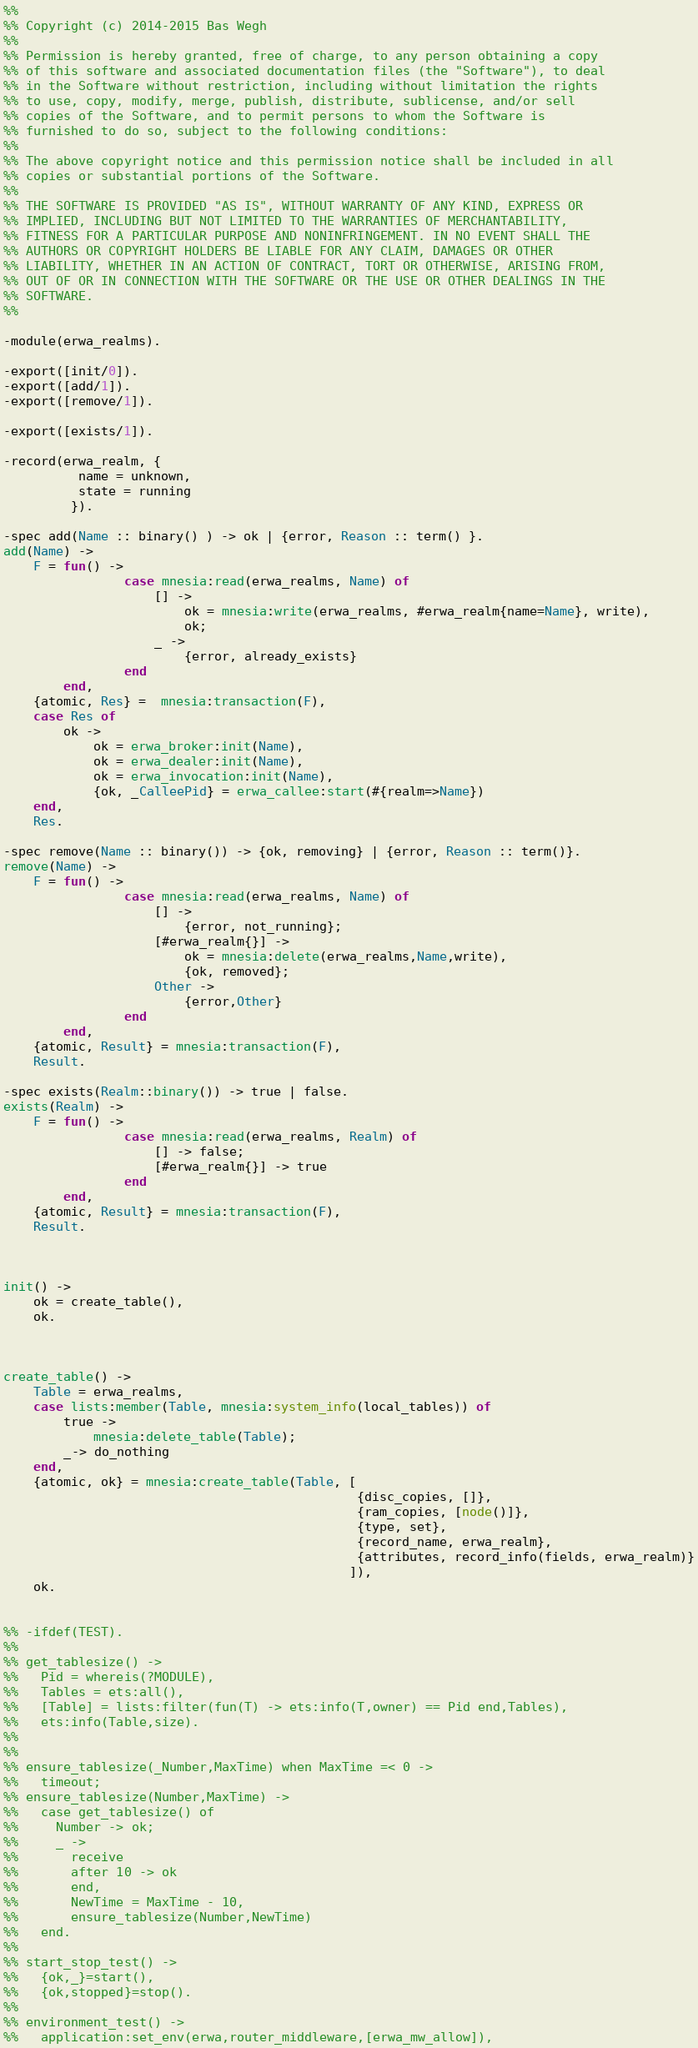<code> <loc_0><loc_0><loc_500><loc_500><_Erlang_>%%
%% Copyright (c) 2014-2015 Bas Wegh
%%
%% Permission is hereby granted, free of charge, to any person obtaining a copy
%% of this software and associated documentation files (the "Software"), to deal
%% in the Software without restriction, including without limitation the rights
%% to use, copy, modify, merge, publish, distribute, sublicense, and/or sell
%% copies of the Software, and to permit persons to whom the Software is
%% furnished to do so, subject to the following conditions:
%%
%% The above copyright notice and this permission notice shall be included in all
%% copies or substantial portions of the Software.
%%
%% THE SOFTWARE IS PROVIDED "AS IS", WITHOUT WARRANTY OF ANY KIND, EXPRESS OR
%% IMPLIED, INCLUDING BUT NOT LIMITED TO THE WARRANTIES OF MERCHANTABILITY,
%% FITNESS FOR A PARTICULAR PURPOSE AND NONINFRINGEMENT. IN NO EVENT SHALL THE
%% AUTHORS OR COPYRIGHT HOLDERS BE LIABLE FOR ANY CLAIM, DAMAGES OR OTHER
%% LIABILITY, WHETHER IN AN ACTION OF CONTRACT, TORT OR OTHERWISE, ARISING FROM,
%% OUT OF OR IN CONNECTION WITH THE SOFTWARE OR THE USE OR OTHER DEALINGS IN THE
%% SOFTWARE.
%%

-module(erwa_realms).

-export([init/0]).
-export([add/1]).
-export([remove/1]).

-export([exists/1]).

-record(erwa_realm, {
          name = unknown,
          state = running
         }).

-spec add(Name :: binary() ) -> ok | {error, Reason :: term() }.
add(Name) ->
    F = fun() -> 
                case mnesia:read(erwa_realms, Name) of 
                    [] ->
                        ok = mnesia:write(erwa_realms, #erwa_realm{name=Name}, write),
                        ok;
                    _ -> 
                        {error, already_exists}
                end 
        end,
    {atomic, Res} =  mnesia:transaction(F),
    case Res of
        ok ->
            ok = erwa_broker:init(Name),
            ok = erwa_dealer:init(Name),
            ok = erwa_invocation:init(Name),
            {ok, _CalleePid} = erwa_callee:start(#{realm=>Name})
    end,
    Res.

-spec remove(Name :: binary()) -> {ok, removing} | {error, Reason :: term()}.
remove(Name) ->
    F = fun() ->
                case mnesia:read(erwa_realms, Name) of
                    [] ->
                        {error, not_running};
                    [#erwa_realm{}] ->
                        ok = mnesia:delete(erwa_realms,Name,write),
                        {ok, removed};
                    Other ->
                        {error,Other}
                end 
        end,
    {atomic, Result} = mnesia:transaction(F),
    Result.

-spec exists(Realm::binary()) -> true | false.
exists(Realm) ->
    F = fun() ->
                case mnesia:read(erwa_realms, Realm) of 
                    [] -> false;
                    [#erwa_realm{}] -> true 
                end 
        end,
    {atomic, Result} = mnesia:transaction(F),
    Result.



init() ->
    ok = create_table(),
    ok.



create_table() ->
    Table = erwa_realms,
	case lists:member(Table, mnesia:system_info(local_tables)) of
		true ->
			mnesia:delete_table(Table);
		_-> do_nothing
	end,
	{atomic, ok} = mnesia:create_table(Table, [
                                               {disc_copies, []},
                                               {ram_copies, [node()]}, 
                                               {type, set},
                                               {record_name, erwa_realm},
                                               {attributes, record_info(fields, erwa_realm)}
                                              ]),
	ok.


%% -ifdef(TEST).
%%
%% get_tablesize() ->
%%   Pid = whereis(?MODULE),
%%   Tables = ets:all(),
%%   [Table] = lists:filter(fun(T) -> ets:info(T,owner) == Pid end,Tables),
%%   ets:info(Table,size).
%%
%%
%% ensure_tablesize(_Number,MaxTime) when MaxTime =< 0 ->
%%   timeout;
%% ensure_tablesize(Number,MaxTime) ->
%%   case get_tablesize() of
%%     Number -> ok;
%%     _ ->
%%       receive
%%       after 10 -> ok
%%       end,
%%       NewTime = MaxTime - 10,
%%       ensure_tablesize(Number,NewTime)
%%   end.
%%
%% start_stop_test() ->
%%   {ok,_}=start(),
%%   {ok,stopped}=stop().
%%
%% environment_test() ->
%%   application:set_env(erwa,router_middleware,[erwa_mw_allow]),</code> 